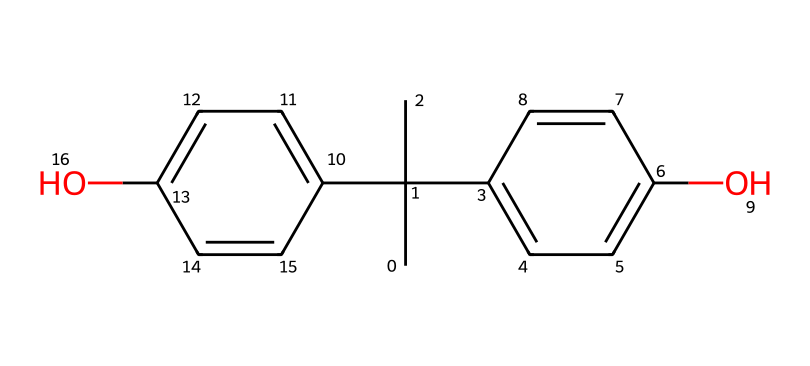What is the molecular formula of bisphenol A? To find the molecular formula, we count the different atoms in the chemical's structure represented by the SMILES notation. Bisphenol A consists of 15 carbon (C) atoms, 16 hydrogen (H) atoms, and 2 oxygen (O) atoms. Combining these, the molecular formula is C15H16O2.
Answer: C15H16O2 How many hydroxyl (–OH) groups are present? In the molecular structure of bisphenol A, we see two hydroxyl (–OH) groups bonded to aromatic rings. Each of the two identifiable phenolic parts in the structure contains one hydroxyl group. Thus, the total is two.
Answer: 2 Which functional group characterizes bisphenol A? The presence of the hydroxyl (–OH) groups in this chemical's structure identifies it as an alcohol. Additionally, the phenolic nature (due to the aromatic rings) categorizes it as a phenol. Thus, the characteristic functional group is hydroxyl.
Answer: hydroxyl What is the degree of saturation in bisphenol A? Degree of saturation reflects the number of double bonds or rings in a compound, which can be determined from the structural representation. Bisphenol A has no rings or double bonds in its carbon structure that create unsaturation. Therefore, the degree of saturation is 0.
Answer: 0 Is bisphenol A considered hazardous? In evaluating the toxicity of bisphenol A, various studies indicate it has been associated with endocrine disruption and other health concerns, confirming its classification as a hazardous substance. Hence, the answer is affirmative.
Answer: yes 